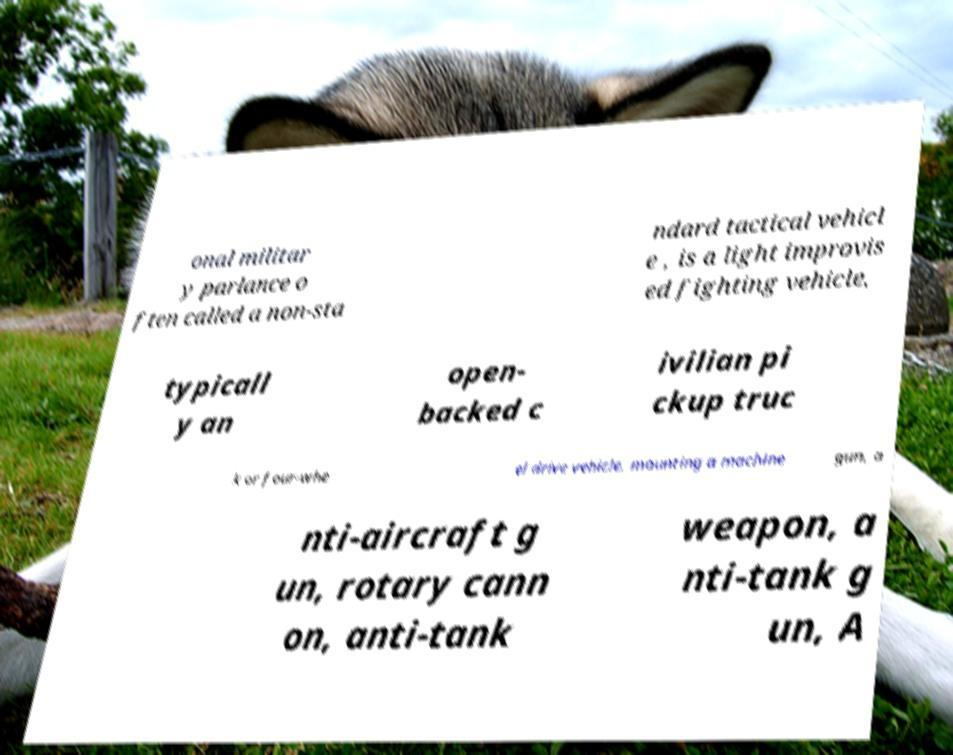What messages or text are displayed in this image? I need them in a readable, typed format. onal militar y parlance o ften called a non-sta ndard tactical vehicl e , is a light improvis ed fighting vehicle, typicall y an open- backed c ivilian pi ckup truc k or four-whe el drive vehicle, mounting a machine gun, a nti-aircraft g un, rotary cann on, anti-tank weapon, a nti-tank g un, A 